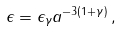Convert formula to latex. <formula><loc_0><loc_0><loc_500><loc_500>\epsilon = \epsilon _ { \gamma } a ^ { - 3 ( 1 + \gamma ) } \, ,</formula> 